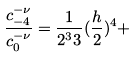Convert formula to latex. <formula><loc_0><loc_0><loc_500><loc_500>\frac { c _ { - 4 } ^ { - \nu } } { c _ { 0 } ^ { - \nu } } = \frac { 1 } { 2 ^ { 3 } 3 } ( \frac { h } { 2 } ) ^ { 4 } +</formula> 